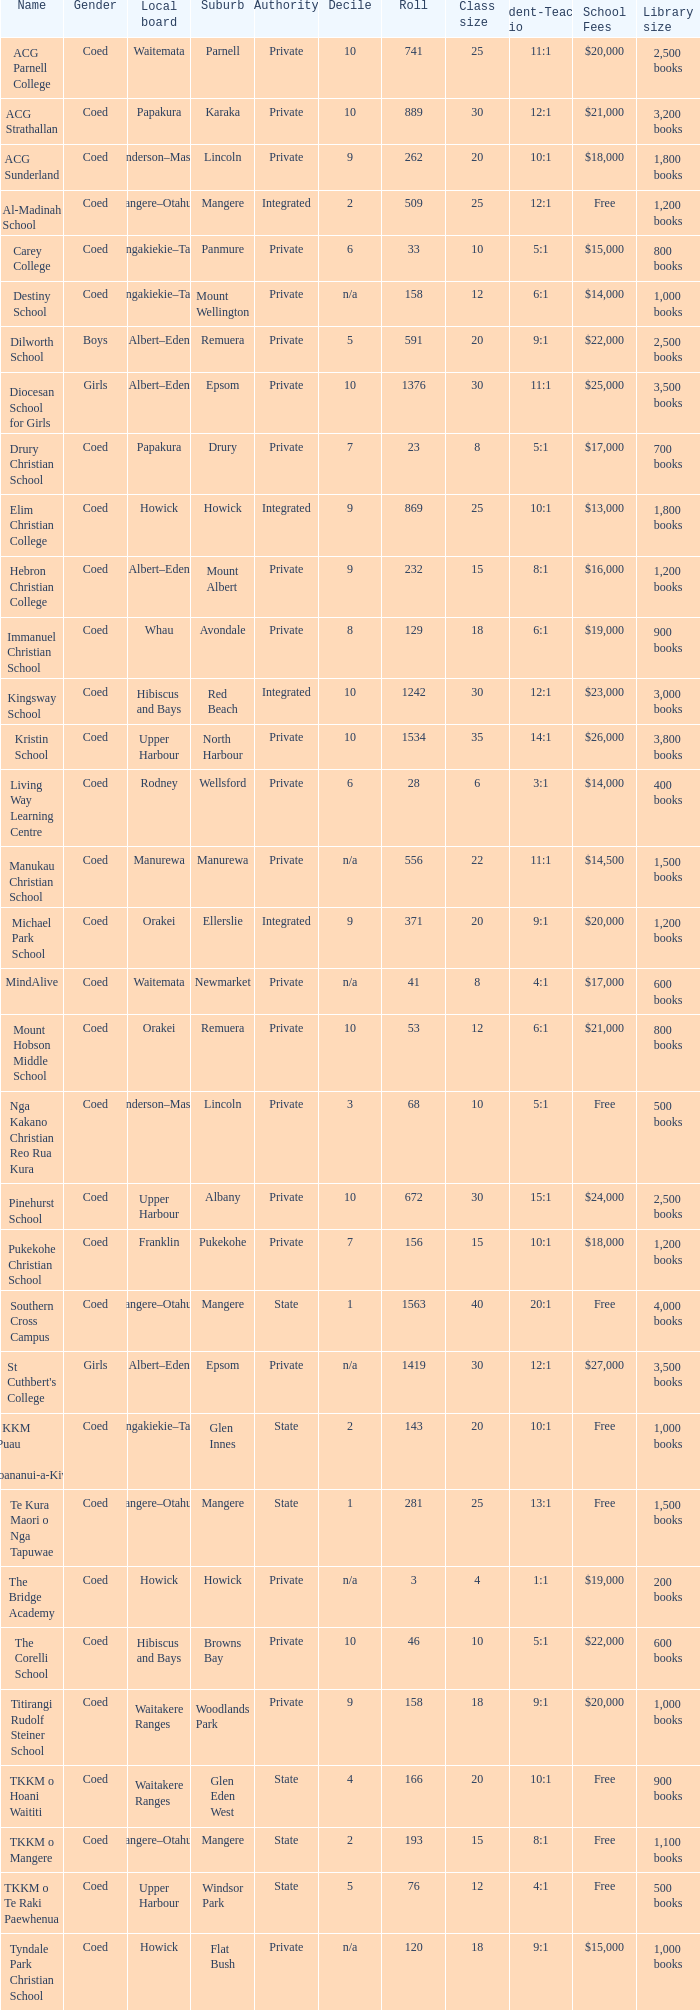What is the name when the local board is albert–eden, and a Decile of 9? Hebron Christian College. 